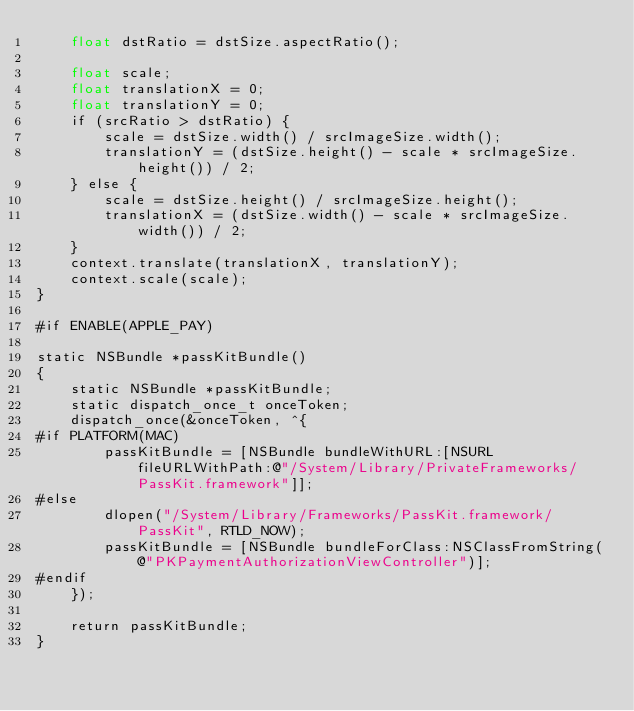Convert code to text. <code><loc_0><loc_0><loc_500><loc_500><_ObjectiveC_>    float dstRatio = dstSize.aspectRatio();

    float scale;
    float translationX = 0;
    float translationY = 0;
    if (srcRatio > dstRatio) {
        scale = dstSize.width() / srcImageSize.width();
        translationY = (dstSize.height() - scale * srcImageSize.height()) / 2;
    } else {
        scale = dstSize.height() / srcImageSize.height();
        translationX = (dstSize.width() - scale * srcImageSize.width()) / 2;
    }
    context.translate(translationX, translationY);
    context.scale(scale);
}

#if ENABLE(APPLE_PAY)

static NSBundle *passKitBundle()
{
    static NSBundle *passKitBundle;
    static dispatch_once_t onceToken;
    dispatch_once(&onceToken, ^{
#if PLATFORM(MAC)
        passKitBundle = [NSBundle bundleWithURL:[NSURL fileURLWithPath:@"/System/Library/PrivateFrameworks/PassKit.framework"]];
#else
        dlopen("/System/Library/Frameworks/PassKit.framework/PassKit", RTLD_NOW);
        passKitBundle = [NSBundle bundleForClass:NSClassFromString(@"PKPaymentAuthorizationViewController")];
#endif
    });

    return passKitBundle;
}
</code> 